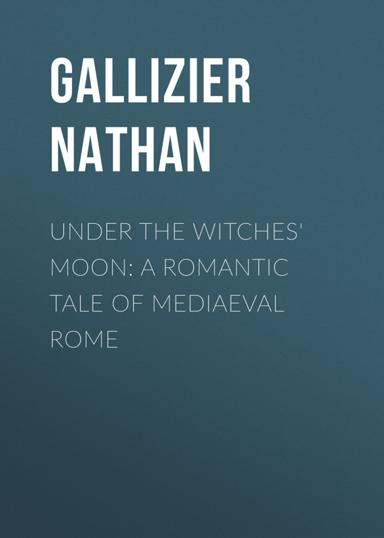What is the title and author of the book mentioned in the image? The book shown in the image is titled "Under the Witches' Moon," authored by Nathan Gallizier. It's a romantic tale set in medieval Rome, offering readers a blend of historical and mystical elements woven through its narrative. 